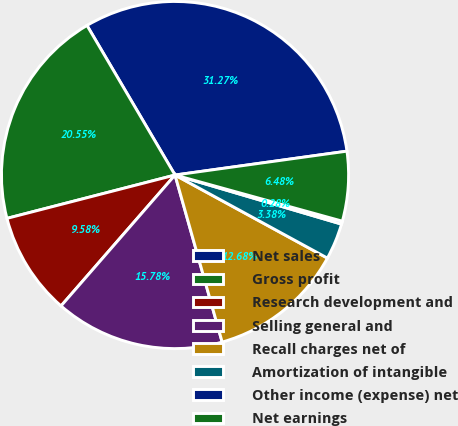<chart> <loc_0><loc_0><loc_500><loc_500><pie_chart><fcel>Net sales<fcel>Gross profit<fcel>Research development and<fcel>Selling general and<fcel>Recall charges net of<fcel>Amortization of intangible<fcel>Other income (expense) net<fcel>Net earnings<nl><fcel>31.27%<fcel>20.55%<fcel>9.58%<fcel>15.78%<fcel>12.68%<fcel>3.38%<fcel>0.28%<fcel>6.48%<nl></chart> 